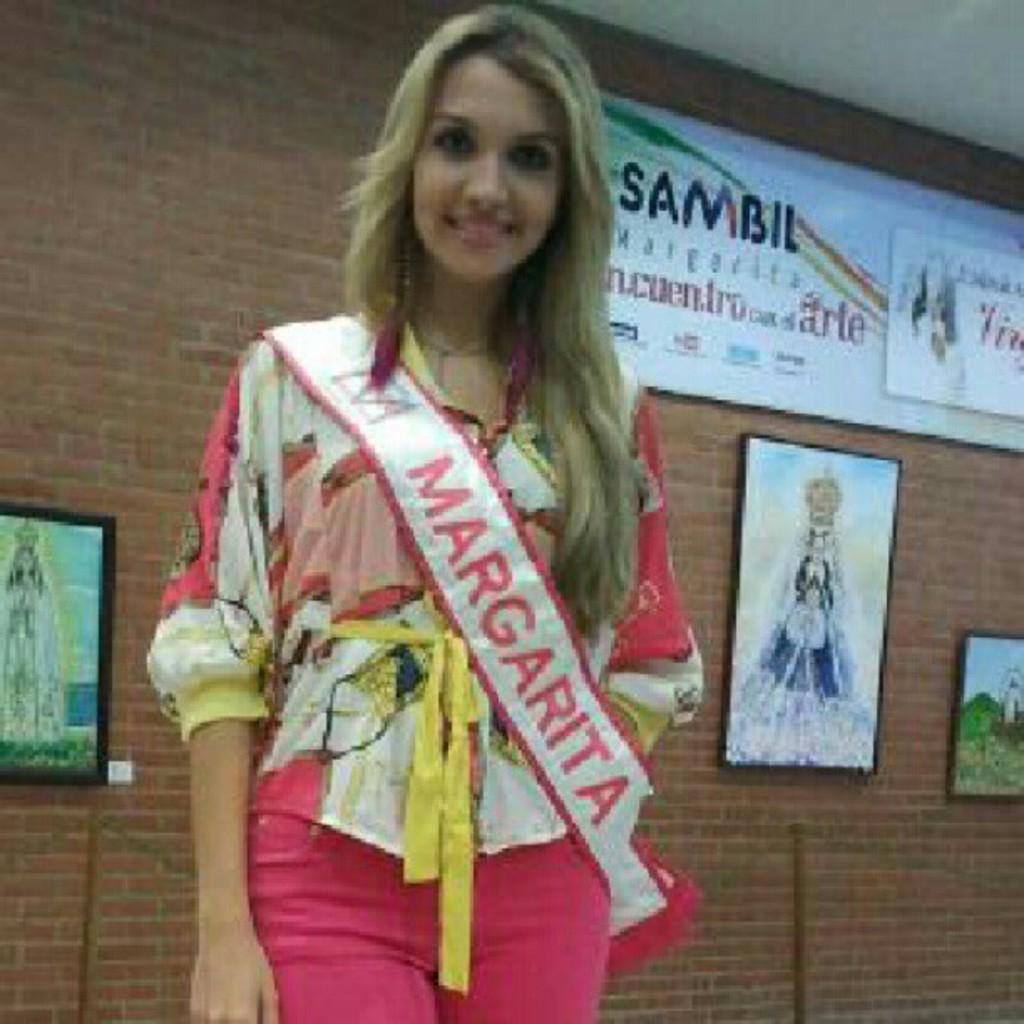Who is present in the image? There is a woman in the image. What can be seen in the background of the image? There is a wall with picture frames and a board with text in the background of the image. What objects are in front of the wall in the background of the image? There are metal rods in front of the wall in the background of the image. What type of sweater is the woman wearing in the image? The provided facts do not mention the type of sweater the woman is wearing, so we cannot answer this question definitively. Where is the truck located in the image? There is no truck present in the image. 